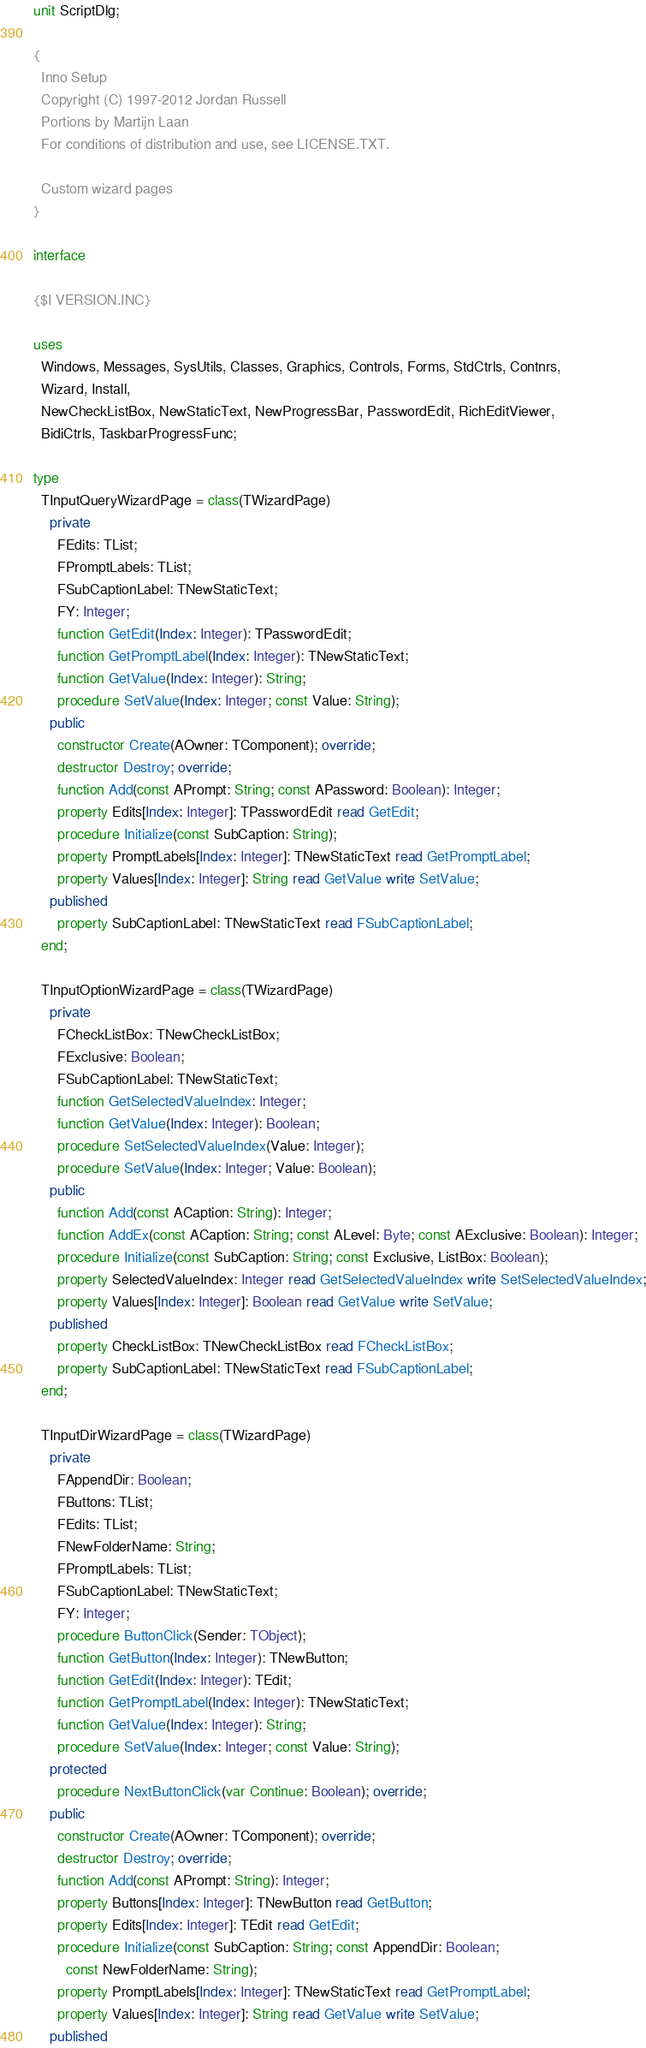Convert code to text. <code><loc_0><loc_0><loc_500><loc_500><_Pascal_>unit ScriptDlg;

{
  Inno Setup
  Copyright (C) 1997-2012 Jordan Russell
  Portions by Martijn Laan
  For conditions of distribution and use, see LICENSE.TXT.

  Custom wizard pages
}

interface

{$I VERSION.INC}

uses
  Windows, Messages, SysUtils, Classes, Graphics, Controls, Forms, StdCtrls, Contnrs,
  Wizard, Install,
  NewCheckListBox, NewStaticText, NewProgressBar, PasswordEdit, RichEditViewer,
  BidiCtrls, TaskbarProgressFunc;

type
  TInputQueryWizardPage = class(TWizardPage)
    private
      FEdits: TList;
      FPromptLabels: TList;
      FSubCaptionLabel: TNewStaticText;
      FY: Integer;
      function GetEdit(Index: Integer): TPasswordEdit;
      function GetPromptLabel(Index: Integer): TNewStaticText;
      function GetValue(Index: Integer): String;
      procedure SetValue(Index: Integer; const Value: String);
    public
      constructor Create(AOwner: TComponent); override;
      destructor Destroy; override;
      function Add(const APrompt: String; const APassword: Boolean): Integer;
      property Edits[Index: Integer]: TPasswordEdit read GetEdit;
      procedure Initialize(const SubCaption: String);
      property PromptLabels[Index: Integer]: TNewStaticText read GetPromptLabel;
      property Values[Index: Integer]: String read GetValue write SetValue;
    published
      property SubCaptionLabel: TNewStaticText read FSubCaptionLabel;
  end;

  TInputOptionWizardPage = class(TWizardPage)
    private
      FCheckListBox: TNewCheckListBox;
      FExclusive: Boolean;
      FSubCaptionLabel: TNewStaticText;
      function GetSelectedValueIndex: Integer;
      function GetValue(Index: Integer): Boolean;
      procedure SetSelectedValueIndex(Value: Integer);
      procedure SetValue(Index: Integer; Value: Boolean);
    public
      function Add(const ACaption: String): Integer;
      function AddEx(const ACaption: String; const ALevel: Byte; const AExclusive: Boolean): Integer;
      procedure Initialize(const SubCaption: String; const Exclusive, ListBox: Boolean);
      property SelectedValueIndex: Integer read GetSelectedValueIndex write SetSelectedValueIndex;
      property Values[Index: Integer]: Boolean read GetValue write SetValue;
    published
      property CheckListBox: TNewCheckListBox read FCheckListBox;
      property SubCaptionLabel: TNewStaticText read FSubCaptionLabel;
  end;

  TInputDirWizardPage = class(TWizardPage)
    private
      FAppendDir: Boolean;
      FButtons: TList;
      FEdits: TList;
      FNewFolderName: String;
      FPromptLabels: TList;
      FSubCaptionLabel: TNewStaticText;
      FY: Integer;
      procedure ButtonClick(Sender: TObject);
      function GetButton(Index: Integer): TNewButton;
      function GetEdit(Index: Integer): TEdit;
      function GetPromptLabel(Index: Integer): TNewStaticText;
      function GetValue(Index: Integer): String;
      procedure SetValue(Index: Integer; const Value: String);
    protected
      procedure NextButtonClick(var Continue: Boolean); override;
    public
      constructor Create(AOwner: TComponent); override;
      destructor Destroy; override;
      function Add(const APrompt: String): Integer;
      property Buttons[Index: Integer]: TNewButton read GetButton;
      property Edits[Index: Integer]: TEdit read GetEdit;
      procedure Initialize(const SubCaption: String; const AppendDir: Boolean;
        const NewFolderName: String);
      property PromptLabels[Index: Integer]: TNewStaticText read GetPromptLabel;
      property Values[Index: Integer]: String read GetValue write SetValue;
    published</code> 